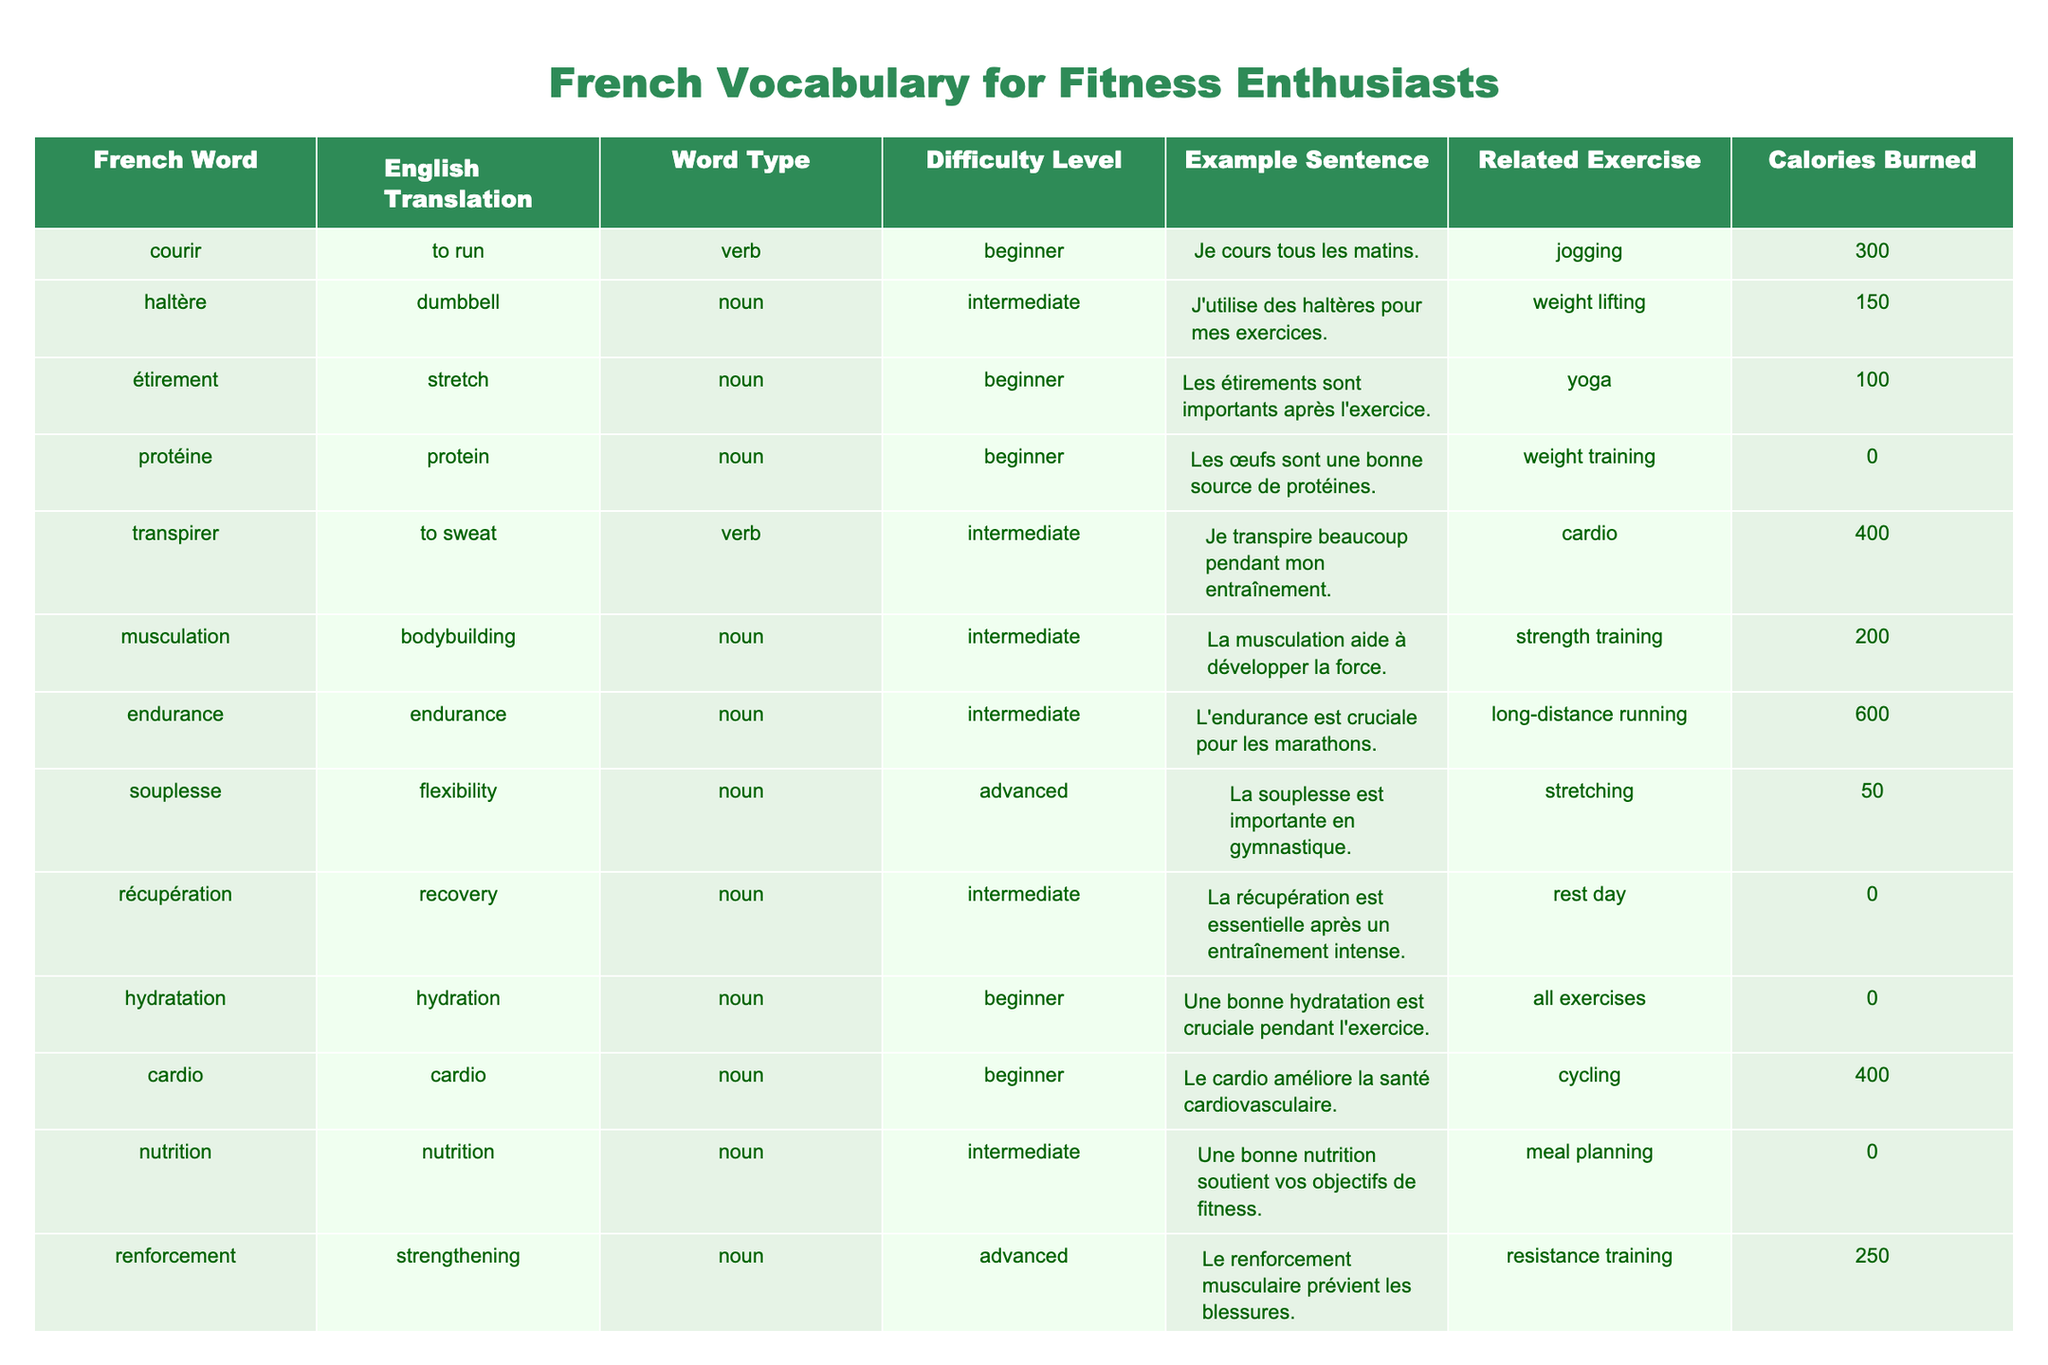What is the French word for "to run"? The table lists the French word "courir" and its translation to English is "to run."
Answer: courir Which word has the highest calories burned associated with it? By examining the "Calories Burned" column, the highest value is 600, which is associated with the word "endurance."
Answer: endurance Is "protéine" a beginner level vocabulary word? In the table, the word "protéine" is listed under the "Difficulty Level" column as beginner.
Answer: Yes What is the calorie difference between "intensité" and "musculation"? The calories burned for "intensité" is 500 and for "musculation" is 200; the difference is 500 - 200 = 300.
Answer: 300 Which exercise is related to the word "étirement"? The related exercise for "étirement" is listed as "yoga" in the table.
Answer: yoga If you sum the calories burned for "hydratation" and "récupération," what is the result? Both "hydratation" and "récupération" have 0 calories burned, so the sum is 0 + 0 = 0.
Answer: 0 What is the English translation of "souplesse"? The table shows that "souplesse" translates to "flexibility" in English.
Answer: flexibility How many words in the table are categorized as advanced vocabulary? The table lists two advanced words: "souplesse" and "intensité," so there are 2 advanced vocabulary words.
Answer: 2 Is there any vocabulary related to cardio that has a beginner difficulty level? Yes, "cardio" is listed in the table with a beginner difficulty level.
Answer: Yes What is the average calories burned for the words listed as "intermediate"? The calories burned for intermediate words are 150 (haltère) + 400 (transpirer) + 200 (musculation) + 600 (endurance) + 150 (équilibre) + 0 (nutrition) = 1500; dividing by 6 gives an average of 250.
Answer: 250 Which word corresponds to the exercise "weight lifting"? The table indicates that "haltère" corresponds to the exercise "weight lifting."
Answer: haltère 